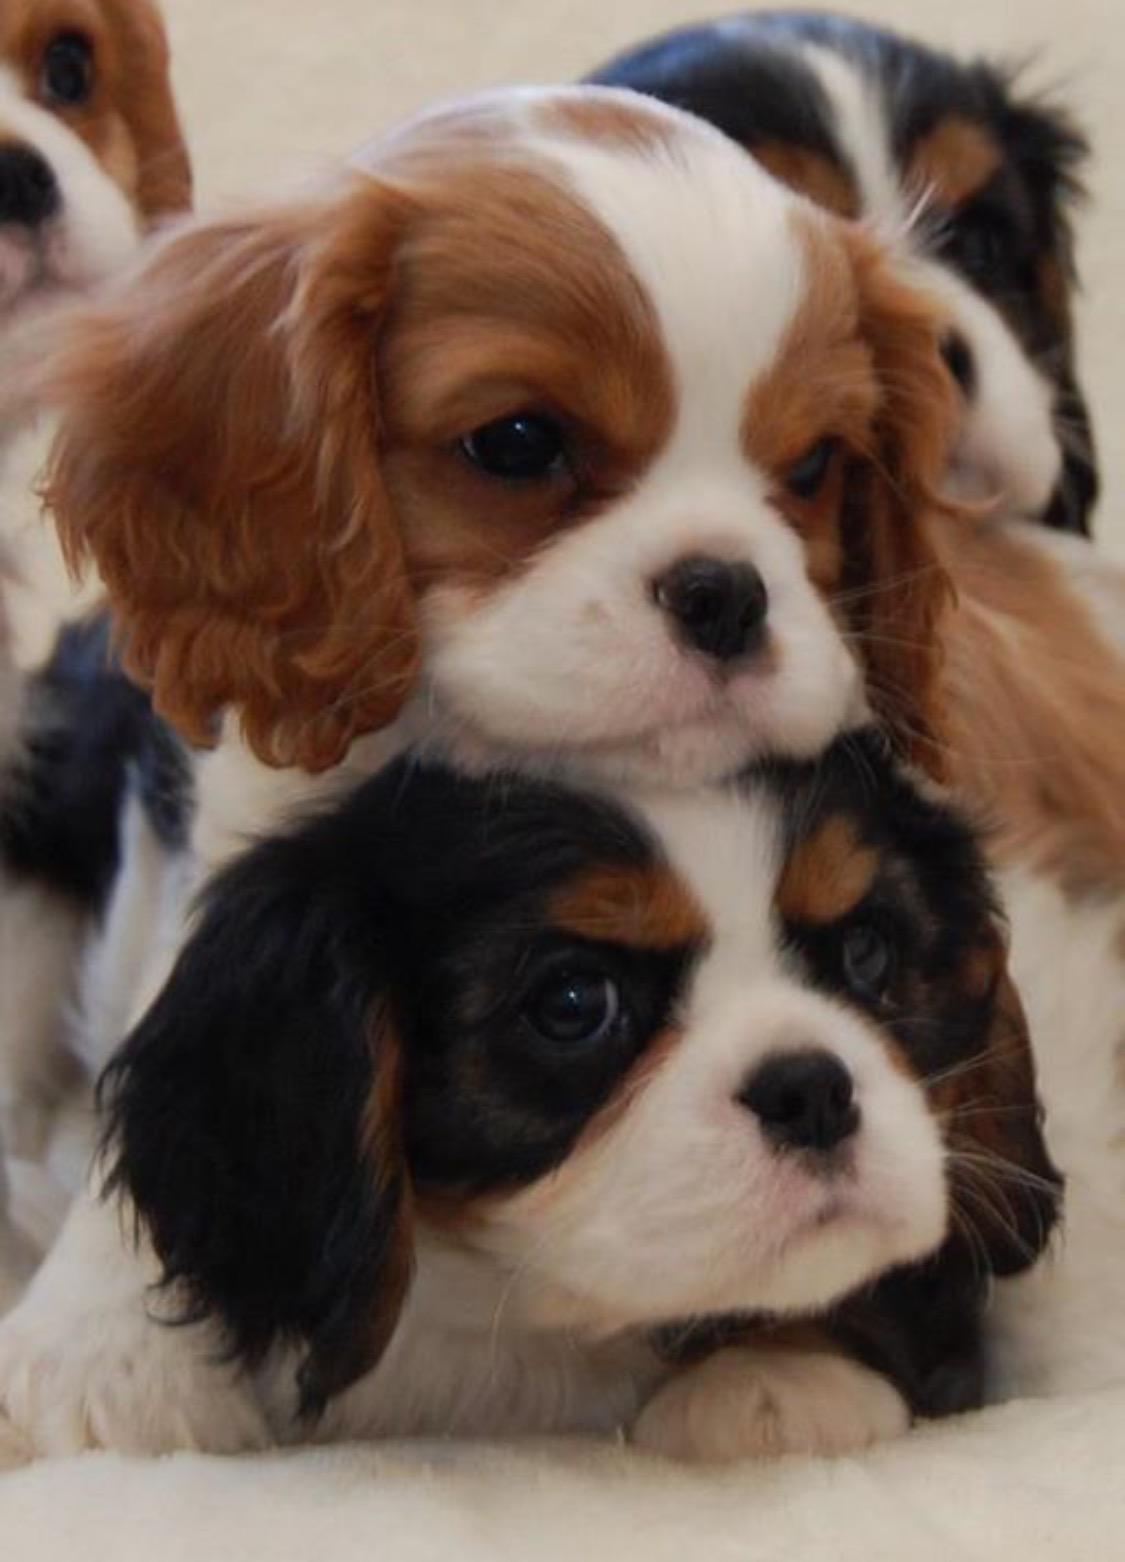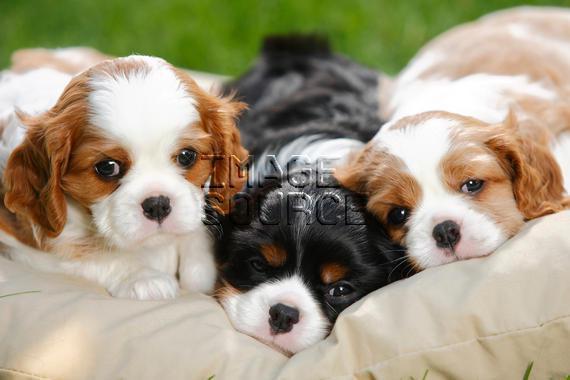The first image is the image on the left, the second image is the image on the right. Assess this claim about the two images: "There are three dogs in one image and two in another.". Correct or not? Answer yes or no. Yes. The first image is the image on the left, the second image is the image on the right. Considering the images on both sides, is "There is exactly three dogs in the right image." valid? Answer yes or no. Yes. 